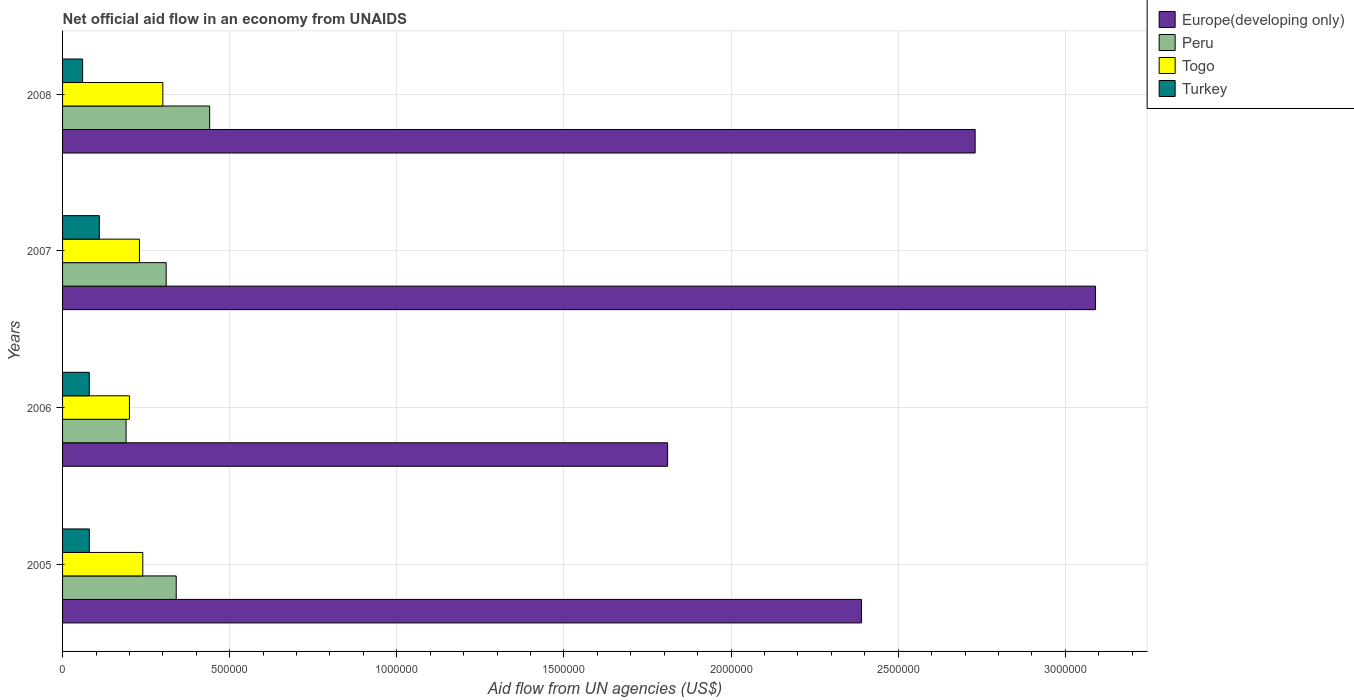How many groups of bars are there?
Provide a short and direct response. 4. Are the number of bars on each tick of the Y-axis equal?
Your answer should be very brief. Yes. What is the net official aid flow in Turkey in 2006?
Your answer should be very brief. 8.00e+04. Across all years, what is the maximum net official aid flow in Europe(developing only)?
Give a very brief answer. 3.09e+06. Across all years, what is the minimum net official aid flow in Turkey?
Ensure brevity in your answer.  6.00e+04. In which year was the net official aid flow in Europe(developing only) minimum?
Keep it short and to the point. 2006. What is the total net official aid flow in Peru in the graph?
Give a very brief answer. 1.28e+06. What is the difference between the net official aid flow in Togo in 2006 and that in 2008?
Keep it short and to the point. -1.00e+05. What is the difference between the net official aid flow in Turkey in 2008 and the net official aid flow in Europe(developing only) in 2007?
Offer a terse response. -3.03e+06. What is the average net official aid flow in Turkey per year?
Make the answer very short. 8.25e+04. In the year 2007, what is the difference between the net official aid flow in Turkey and net official aid flow in Togo?
Provide a short and direct response. -1.20e+05. What is the ratio of the net official aid flow in Europe(developing only) in 2006 to that in 2007?
Offer a very short reply. 0.59. Is the net official aid flow in Turkey in 2005 less than that in 2007?
Make the answer very short. Yes. Is the difference between the net official aid flow in Turkey in 2006 and 2007 greater than the difference between the net official aid flow in Togo in 2006 and 2007?
Give a very brief answer. No. What is the difference between the highest and the lowest net official aid flow in Togo?
Provide a short and direct response. 1.00e+05. In how many years, is the net official aid flow in Togo greater than the average net official aid flow in Togo taken over all years?
Make the answer very short. 1. What does the 4th bar from the top in 2005 represents?
Give a very brief answer. Europe(developing only). Are all the bars in the graph horizontal?
Give a very brief answer. Yes. Does the graph contain grids?
Your answer should be compact. Yes. Where does the legend appear in the graph?
Offer a terse response. Top right. What is the title of the graph?
Make the answer very short. Net official aid flow in an economy from UNAIDS. What is the label or title of the X-axis?
Your answer should be very brief. Aid flow from UN agencies (US$). What is the label or title of the Y-axis?
Your answer should be very brief. Years. What is the Aid flow from UN agencies (US$) in Europe(developing only) in 2005?
Give a very brief answer. 2.39e+06. What is the Aid flow from UN agencies (US$) in Peru in 2005?
Ensure brevity in your answer.  3.40e+05. What is the Aid flow from UN agencies (US$) of Togo in 2005?
Keep it short and to the point. 2.40e+05. What is the Aid flow from UN agencies (US$) in Europe(developing only) in 2006?
Make the answer very short. 1.81e+06. What is the Aid flow from UN agencies (US$) of Europe(developing only) in 2007?
Give a very brief answer. 3.09e+06. What is the Aid flow from UN agencies (US$) of Peru in 2007?
Your answer should be very brief. 3.10e+05. What is the Aid flow from UN agencies (US$) of Turkey in 2007?
Your answer should be very brief. 1.10e+05. What is the Aid flow from UN agencies (US$) of Europe(developing only) in 2008?
Your answer should be compact. 2.73e+06. What is the Aid flow from UN agencies (US$) in Peru in 2008?
Provide a short and direct response. 4.40e+05. Across all years, what is the maximum Aid flow from UN agencies (US$) of Europe(developing only)?
Your response must be concise. 3.09e+06. Across all years, what is the maximum Aid flow from UN agencies (US$) of Peru?
Your answer should be very brief. 4.40e+05. Across all years, what is the maximum Aid flow from UN agencies (US$) in Turkey?
Ensure brevity in your answer.  1.10e+05. Across all years, what is the minimum Aid flow from UN agencies (US$) of Europe(developing only)?
Provide a succinct answer. 1.81e+06. Across all years, what is the minimum Aid flow from UN agencies (US$) in Peru?
Your answer should be very brief. 1.90e+05. What is the total Aid flow from UN agencies (US$) of Europe(developing only) in the graph?
Your response must be concise. 1.00e+07. What is the total Aid flow from UN agencies (US$) of Peru in the graph?
Give a very brief answer. 1.28e+06. What is the total Aid flow from UN agencies (US$) of Togo in the graph?
Keep it short and to the point. 9.70e+05. What is the difference between the Aid flow from UN agencies (US$) in Europe(developing only) in 2005 and that in 2006?
Your answer should be very brief. 5.80e+05. What is the difference between the Aid flow from UN agencies (US$) in Peru in 2005 and that in 2006?
Give a very brief answer. 1.50e+05. What is the difference between the Aid flow from UN agencies (US$) in Turkey in 2005 and that in 2006?
Ensure brevity in your answer.  0. What is the difference between the Aid flow from UN agencies (US$) of Europe(developing only) in 2005 and that in 2007?
Your response must be concise. -7.00e+05. What is the difference between the Aid flow from UN agencies (US$) in Peru in 2005 and that in 2007?
Give a very brief answer. 3.00e+04. What is the difference between the Aid flow from UN agencies (US$) in Togo in 2005 and that in 2007?
Offer a very short reply. 10000. What is the difference between the Aid flow from UN agencies (US$) of Europe(developing only) in 2006 and that in 2007?
Offer a very short reply. -1.28e+06. What is the difference between the Aid flow from UN agencies (US$) of Peru in 2006 and that in 2007?
Your answer should be compact. -1.20e+05. What is the difference between the Aid flow from UN agencies (US$) in Togo in 2006 and that in 2007?
Offer a very short reply. -3.00e+04. What is the difference between the Aid flow from UN agencies (US$) in Turkey in 2006 and that in 2007?
Give a very brief answer. -3.00e+04. What is the difference between the Aid flow from UN agencies (US$) in Europe(developing only) in 2006 and that in 2008?
Offer a very short reply. -9.20e+05. What is the difference between the Aid flow from UN agencies (US$) in Turkey in 2006 and that in 2008?
Provide a short and direct response. 2.00e+04. What is the difference between the Aid flow from UN agencies (US$) in Togo in 2007 and that in 2008?
Keep it short and to the point. -7.00e+04. What is the difference between the Aid flow from UN agencies (US$) in Turkey in 2007 and that in 2008?
Offer a terse response. 5.00e+04. What is the difference between the Aid flow from UN agencies (US$) of Europe(developing only) in 2005 and the Aid flow from UN agencies (US$) of Peru in 2006?
Your answer should be compact. 2.20e+06. What is the difference between the Aid flow from UN agencies (US$) of Europe(developing only) in 2005 and the Aid flow from UN agencies (US$) of Togo in 2006?
Provide a short and direct response. 2.19e+06. What is the difference between the Aid flow from UN agencies (US$) in Europe(developing only) in 2005 and the Aid flow from UN agencies (US$) in Turkey in 2006?
Offer a very short reply. 2.31e+06. What is the difference between the Aid flow from UN agencies (US$) of Peru in 2005 and the Aid flow from UN agencies (US$) of Togo in 2006?
Make the answer very short. 1.40e+05. What is the difference between the Aid flow from UN agencies (US$) of Europe(developing only) in 2005 and the Aid flow from UN agencies (US$) of Peru in 2007?
Your answer should be very brief. 2.08e+06. What is the difference between the Aid flow from UN agencies (US$) of Europe(developing only) in 2005 and the Aid flow from UN agencies (US$) of Togo in 2007?
Offer a very short reply. 2.16e+06. What is the difference between the Aid flow from UN agencies (US$) in Europe(developing only) in 2005 and the Aid flow from UN agencies (US$) in Turkey in 2007?
Offer a very short reply. 2.28e+06. What is the difference between the Aid flow from UN agencies (US$) of Peru in 2005 and the Aid flow from UN agencies (US$) of Turkey in 2007?
Keep it short and to the point. 2.30e+05. What is the difference between the Aid flow from UN agencies (US$) of Togo in 2005 and the Aid flow from UN agencies (US$) of Turkey in 2007?
Make the answer very short. 1.30e+05. What is the difference between the Aid flow from UN agencies (US$) of Europe(developing only) in 2005 and the Aid flow from UN agencies (US$) of Peru in 2008?
Offer a terse response. 1.95e+06. What is the difference between the Aid flow from UN agencies (US$) of Europe(developing only) in 2005 and the Aid flow from UN agencies (US$) of Togo in 2008?
Make the answer very short. 2.09e+06. What is the difference between the Aid flow from UN agencies (US$) in Europe(developing only) in 2005 and the Aid flow from UN agencies (US$) in Turkey in 2008?
Your answer should be very brief. 2.33e+06. What is the difference between the Aid flow from UN agencies (US$) in Europe(developing only) in 2006 and the Aid flow from UN agencies (US$) in Peru in 2007?
Your response must be concise. 1.50e+06. What is the difference between the Aid flow from UN agencies (US$) in Europe(developing only) in 2006 and the Aid flow from UN agencies (US$) in Togo in 2007?
Give a very brief answer. 1.58e+06. What is the difference between the Aid flow from UN agencies (US$) in Europe(developing only) in 2006 and the Aid flow from UN agencies (US$) in Turkey in 2007?
Give a very brief answer. 1.70e+06. What is the difference between the Aid flow from UN agencies (US$) in Peru in 2006 and the Aid flow from UN agencies (US$) in Turkey in 2007?
Your answer should be very brief. 8.00e+04. What is the difference between the Aid flow from UN agencies (US$) in Europe(developing only) in 2006 and the Aid flow from UN agencies (US$) in Peru in 2008?
Your answer should be compact. 1.37e+06. What is the difference between the Aid flow from UN agencies (US$) in Europe(developing only) in 2006 and the Aid flow from UN agencies (US$) in Togo in 2008?
Your response must be concise. 1.51e+06. What is the difference between the Aid flow from UN agencies (US$) of Europe(developing only) in 2006 and the Aid flow from UN agencies (US$) of Turkey in 2008?
Your response must be concise. 1.75e+06. What is the difference between the Aid flow from UN agencies (US$) in Peru in 2006 and the Aid flow from UN agencies (US$) in Togo in 2008?
Provide a short and direct response. -1.10e+05. What is the difference between the Aid flow from UN agencies (US$) of Peru in 2006 and the Aid flow from UN agencies (US$) of Turkey in 2008?
Keep it short and to the point. 1.30e+05. What is the difference between the Aid flow from UN agencies (US$) of Europe(developing only) in 2007 and the Aid flow from UN agencies (US$) of Peru in 2008?
Provide a short and direct response. 2.65e+06. What is the difference between the Aid flow from UN agencies (US$) of Europe(developing only) in 2007 and the Aid flow from UN agencies (US$) of Togo in 2008?
Give a very brief answer. 2.79e+06. What is the difference between the Aid flow from UN agencies (US$) in Europe(developing only) in 2007 and the Aid flow from UN agencies (US$) in Turkey in 2008?
Ensure brevity in your answer.  3.03e+06. What is the difference between the Aid flow from UN agencies (US$) of Peru in 2007 and the Aid flow from UN agencies (US$) of Turkey in 2008?
Keep it short and to the point. 2.50e+05. What is the difference between the Aid flow from UN agencies (US$) in Togo in 2007 and the Aid flow from UN agencies (US$) in Turkey in 2008?
Provide a short and direct response. 1.70e+05. What is the average Aid flow from UN agencies (US$) in Europe(developing only) per year?
Make the answer very short. 2.50e+06. What is the average Aid flow from UN agencies (US$) in Peru per year?
Keep it short and to the point. 3.20e+05. What is the average Aid flow from UN agencies (US$) in Togo per year?
Provide a short and direct response. 2.42e+05. What is the average Aid flow from UN agencies (US$) of Turkey per year?
Offer a very short reply. 8.25e+04. In the year 2005, what is the difference between the Aid flow from UN agencies (US$) in Europe(developing only) and Aid flow from UN agencies (US$) in Peru?
Provide a short and direct response. 2.05e+06. In the year 2005, what is the difference between the Aid flow from UN agencies (US$) in Europe(developing only) and Aid flow from UN agencies (US$) in Togo?
Give a very brief answer. 2.15e+06. In the year 2005, what is the difference between the Aid flow from UN agencies (US$) of Europe(developing only) and Aid flow from UN agencies (US$) of Turkey?
Keep it short and to the point. 2.31e+06. In the year 2005, what is the difference between the Aid flow from UN agencies (US$) in Togo and Aid flow from UN agencies (US$) in Turkey?
Provide a succinct answer. 1.60e+05. In the year 2006, what is the difference between the Aid flow from UN agencies (US$) of Europe(developing only) and Aid flow from UN agencies (US$) of Peru?
Provide a short and direct response. 1.62e+06. In the year 2006, what is the difference between the Aid flow from UN agencies (US$) of Europe(developing only) and Aid flow from UN agencies (US$) of Togo?
Offer a terse response. 1.61e+06. In the year 2006, what is the difference between the Aid flow from UN agencies (US$) of Europe(developing only) and Aid flow from UN agencies (US$) of Turkey?
Ensure brevity in your answer.  1.73e+06. In the year 2007, what is the difference between the Aid flow from UN agencies (US$) of Europe(developing only) and Aid flow from UN agencies (US$) of Peru?
Ensure brevity in your answer.  2.78e+06. In the year 2007, what is the difference between the Aid flow from UN agencies (US$) in Europe(developing only) and Aid flow from UN agencies (US$) in Togo?
Give a very brief answer. 2.86e+06. In the year 2007, what is the difference between the Aid flow from UN agencies (US$) in Europe(developing only) and Aid flow from UN agencies (US$) in Turkey?
Your answer should be very brief. 2.98e+06. In the year 2007, what is the difference between the Aid flow from UN agencies (US$) of Togo and Aid flow from UN agencies (US$) of Turkey?
Ensure brevity in your answer.  1.20e+05. In the year 2008, what is the difference between the Aid flow from UN agencies (US$) of Europe(developing only) and Aid flow from UN agencies (US$) of Peru?
Your answer should be compact. 2.29e+06. In the year 2008, what is the difference between the Aid flow from UN agencies (US$) in Europe(developing only) and Aid flow from UN agencies (US$) in Togo?
Provide a succinct answer. 2.43e+06. In the year 2008, what is the difference between the Aid flow from UN agencies (US$) in Europe(developing only) and Aid flow from UN agencies (US$) in Turkey?
Your response must be concise. 2.67e+06. In the year 2008, what is the difference between the Aid flow from UN agencies (US$) of Peru and Aid flow from UN agencies (US$) of Turkey?
Offer a terse response. 3.80e+05. What is the ratio of the Aid flow from UN agencies (US$) in Europe(developing only) in 2005 to that in 2006?
Keep it short and to the point. 1.32. What is the ratio of the Aid flow from UN agencies (US$) of Peru in 2005 to that in 2006?
Provide a short and direct response. 1.79. What is the ratio of the Aid flow from UN agencies (US$) of Europe(developing only) in 2005 to that in 2007?
Keep it short and to the point. 0.77. What is the ratio of the Aid flow from UN agencies (US$) of Peru in 2005 to that in 2007?
Make the answer very short. 1.1. What is the ratio of the Aid flow from UN agencies (US$) of Togo in 2005 to that in 2007?
Offer a very short reply. 1.04. What is the ratio of the Aid flow from UN agencies (US$) of Turkey in 2005 to that in 2007?
Your answer should be very brief. 0.73. What is the ratio of the Aid flow from UN agencies (US$) in Europe(developing only) in 2005 to that in 2008?
Your response must be concise. 0.88. What is the ratio of the Aid flow from UN agencies (US$) in Peru in 2005 to that in 2008?
Ensure brevity in your answer.  0.77. What is the ratio of the Aid flow from UN agencies (US$) in Togo in 2005 to that in 2008?
Ensure brevity in your answer.  0.8. What is the ratio of the Aid flow from UN agencies (US$) in Turkey in 2005 to that in 2008?
Provide a short and direct response. 1.33. What is the ratio of the Aid flow from UN agencies (US$) of Europe(developing only) in 2006 to that in 2007?
Your response must be concise. 0.59. What is the ratio of the Aid flow from UN agencies (US$) of Peru in 2006 to that in 2007?
Provide a short and direct response. 0.61. What is the ratio of the Aid flow from UN agencies (US$) of Togo in 2006 to that in 2007?
Offer a very short reply. 0.87. What is the ratio of the Aid flow from UN agencies (US$) in Turkey in 2006 to that in 2007?
Your answer should be very brief. 0.73. What is the ratio of the Aid flow from UN agencies (US$) of Europe(developing only) in 2006 to that in 2008?
Keep it short and to the point. 0.66. What is the ratio of the Aid flow from UN agencies (US$) in Peru in 2006 to that in 2008?
Provide a short and direct response. 0.43. What is the ratio of the Aid flow from UN agencies (US$) in Europe(developing only) in 2007 to that in 2008?
Ensure brevity in your answer.  1.13. What is the ratio of the Aid flow from UN agencies (US$) in Peru in 2007 to that in 2008?
Make the answer very short. 0.7. What is the ratio of the Aid flow from UN agencies (US$) of Togo in 2007 to that in 2008?
Give a very brief answer. 0.77. What is the ratio of the Aid flow from UN agencies (US$) in Turkey in 2007 to that in 2008?
Give a very brief answer. 1.83. What is the difference between the highest and the second highest Aid flow from UN agencies (US$) of Europe(developing only)?
Offer a terse response. 3.60e+05. What is the difference between the highest and the second highest Aid flow from UN agencies (US$) of Peru?
Keep it short and to the point. 1.00e+05. What is the difference between the highest and the lowest Aid flow from UN agencies (US$) of Europe(developing only)?
Your answer should be compact. 1.28e+06. What is the difference between the highest and the lowest Aid flow from UN agencies (US$) in Togo?
Make the answer very short. 1.00e+05. What is the difference between the highest and the lowest Aid flow from UN agencies (US$) in Turkey?
Offer a very short reply. 5.00e+04. 